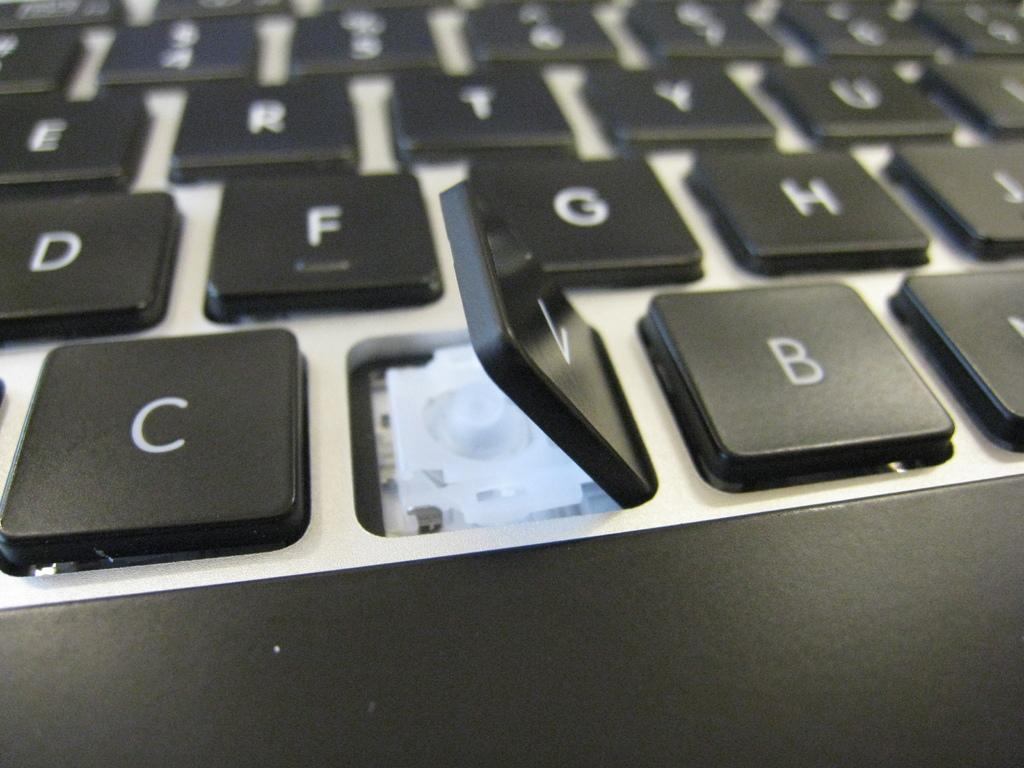<image>
Create a compact narrative representing the image presented. A keyboard on which the letter "V" key has been lifted. 